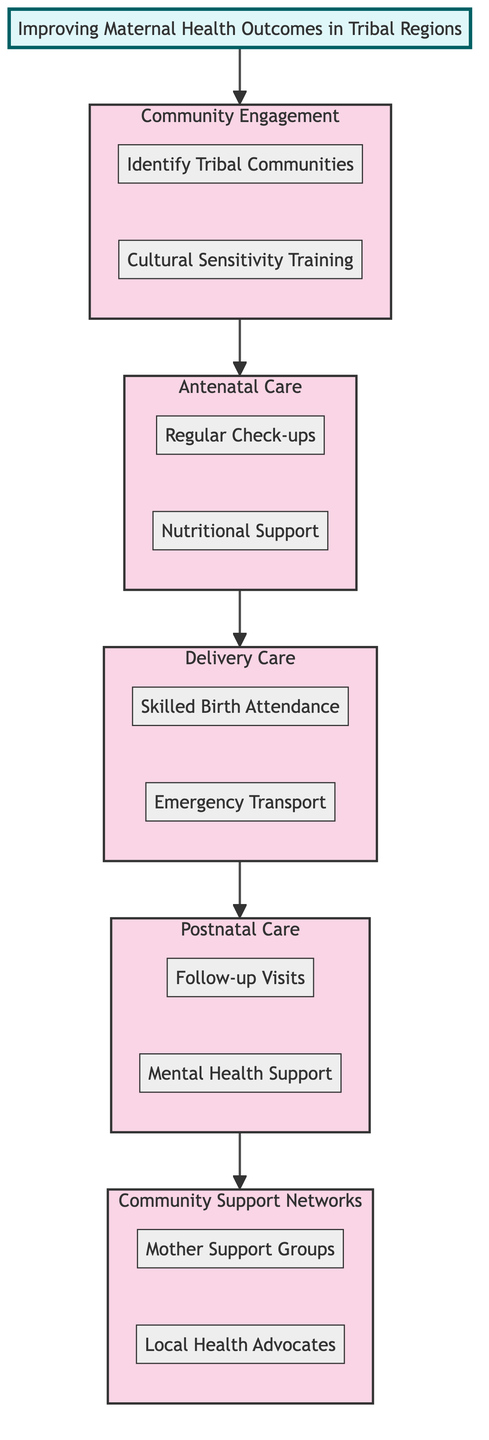What is the first stage in the clinical pathway? The first stage is labeled 'Community Engagement' in the diagram, indicating the initial focus area for improving maternal health outcomes.
Answer: Community Engagement How many main stages are there in the clinical pathway? The diagram contains five main stages connected in sequence: Community Engagement, Antenatal Care, Delivery Care, Postnatal Care, and Community Support Networks. Thus, the total number is five.
Answer: 5 Which task is associated with the 'Postnatal Care' stage? The 'Postnatal Care' stage has two tasks included: 'Follow-up Visits' and 'Mental Health Support', both contributing to the maternal health process after childbirth.
Answer: Follow-up Visits, Mental Health Support What type of support is provided in the 'Community Support Networks' stage? This stage includes the establishment of 'Mother Support Groups' and training of 'Local Health Advocates' to foster community involvement in maternal health.
Answer: Mother Support Groups, Local Health Advocates What is the relationship between 'Delivery Care' and 'Antenatal Care'? The relationship is sequential; 'Antenatal Care' must be conducted before 'Delivery Care', indicating the pathway of care progresses from antenatal visits to delivery services.
Answer: Sequential Which task focuses on the involvement of local healthcare providers? The task 'Skilled Birth Attendance' focuses on ensuring that trained healthcare providers are present during the delivery, emphasizing professional involvement in Maternal Health.
Answer: Skilled Birth Attendance What is required for emergency situations in the 'Delivery Care' stage? The 'Emergency Transport' task establishes the need for reliable systems to transport mothers in complicated delivery situations, highlighting a crucial element of this care stage.
Answer: Emergency Transport How does the 'Community Engagement' stage facilitate health outcomes? It facilitates health outcomes by both identifying tribal communities and providing cultural sensitivity training for healthcare workers, which are foundational steps to build trust and service effectiveness.
Answer: Identify Tribal Communities, Cultural Sensitivity Training Which stage does 'Regular Check-ups' belong to? The task 'Regular Check-ups' belongs to the 'Antenatal Care' stage, as it aims to ensure expectant mothers receive the necessary prenatal health visits.
Answer: Antenatal Care 